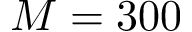Convert formula to latex. <formula><loc_0><loc_0><loc_500><loc_500>M = 3 0 0</formula> 